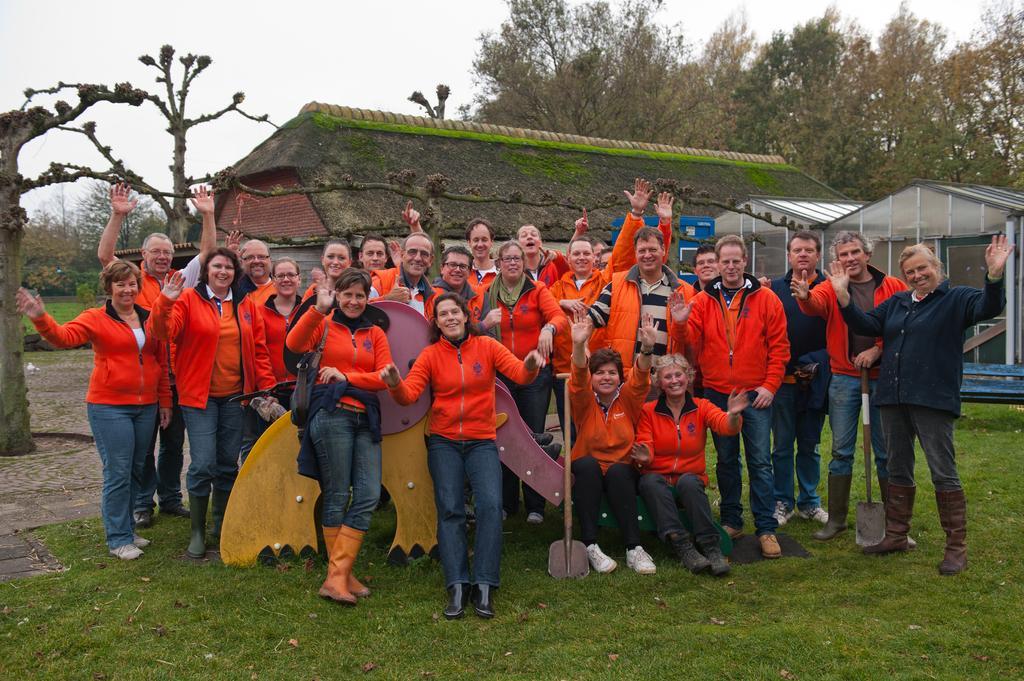Please provide a concise description of this image. As we can see in the image in the front there are group of people wearing red color jackets and standing. These two are wearing black color jackets. In the background there are houses, trees and there is a sky. 